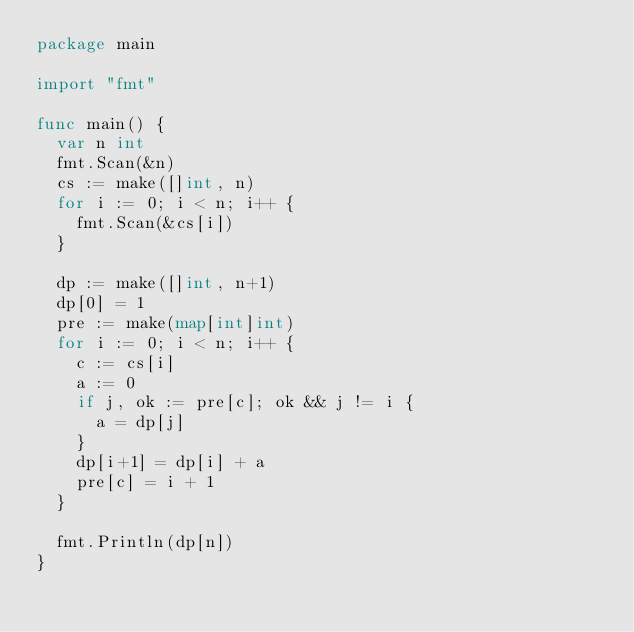Convert code to text. <code><loc_0><loc_0><loc_500><loc_500><_Go_>package main

import "fmt"

func main() {
	var n int
	fmt.Scan(&n)
	cs := make([]int, n)
	for i := 0; i < n; i++ {
		fmt.Scan(&cs[i])
	}

	dp := make([]int, n+1)
	dp[0] = 1
	pre := make(map[int]int)
	for i := 0; i < n; i++ {
		c := cs[i]
		a := 0
		if j, ok := pre[c]; ok && j != i {
			a = dp[j]
		}
		dp[i+1] = dp[i] + a
		pre[c] = i + 1
	}

	fmt.Println(dp[n])
}
</code> 